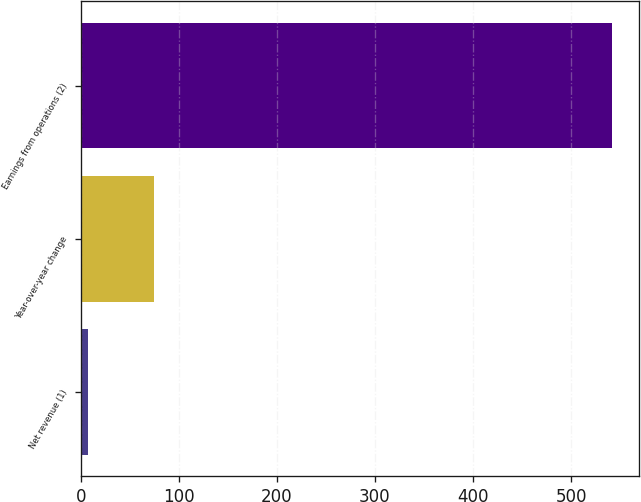<chart> <loc_0><loc_0><loc_500><loc_500><bar_chart><fcel>Net revenue (1)<fcel>Year-over-year change<fcel>Earnings from operations (2)<nl><fcel>7<fcel>75<fcel>542<nl></chart> 